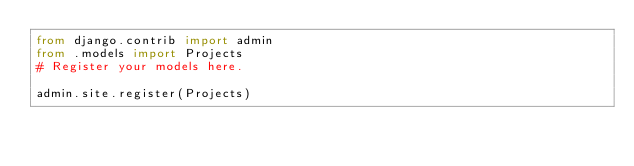<code> <loc_0><loc_0><loc_500><loc_500><_Python_>from django.contrib import admin
from .models import Projects
# Register your models here.

admin.site.register(Projects)
</code> 